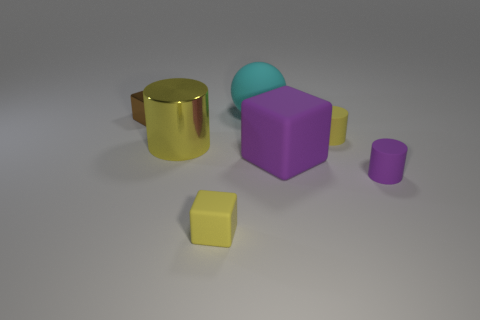There is a matte cylinder that is the same color as the large cube; what is its size?
Make the answer very short. Small. What number of other things are the same size as the purple block?
Offer a very short reply. 2. Is the color of the large metal thing the same as the small block right of the small metal object?
Give a very brief answer. Yes. Are there fewer purple rubber cylinders that are right of the big ball than objects that are left of the small yellow cylinder?
Offer a very short reply. Yes. There is a object that is in front of the large purple matte object and left of the rubber sphere; what color is it?
Provide a short and direct response. Yellow. Does the cyan rubber sphere have the same size as the yellow cylinder left of the large purple object?
Provide a succinct answer. Yes. There is a rubber object that is behind the tiny brown metal cube; what shape is it?
Your response must be concise. Sphere. Are there more brown objects left of the big purple thing than tiny cyan things?
Your answer should be compact. Yes. There is a tiny yellow thing right of the large rubber object that is on the left side of the large cube; what number of tiny objects are in front of it?
Provide a short and direct response. 2. Is the size of the yellow rubber object to the left of the big rubber block the same as the rubber object that is behind the small yellow cylinder?
Keep it short and to the point. No. 